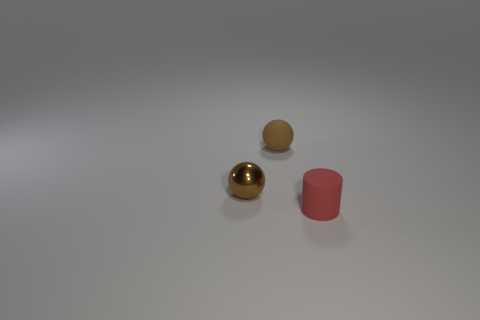How many cylinders are either tiny objects or small metal objects?
Ensure brevity in your answer.  1. Are there any other things of the same shape as the tiny brown shiny thing?
Offer a very short reply. Yes. How many other things are the same color as the matte sphere?
Make the answer very short. 1. Are there fewer rubber things right of the red cylinder than red objects?
Ensure brevity in your answer.  Yes. How many small shiny objects are there?
Make the answer very short. 1. What number of objects have the same material as the cylinder?
Provide a succinct answer. 1. How many objects are small matte things that are to the left of the rubber cylinder or gray blocks?
Offer a terse response. 1. Are there fewer brown metal objects in front of the brown metallic object than brown matte balls left of the small red thing?
Your answer should be compact. Yes. Are there any red rubber cylinders in front of the red cylinder?
Give a very brief answer. No. How many objects are either small brown things that are on the left side of the tiny brown rubber thing or tiny things right of the brown shiny thing?
Give a very brief answer. 3. 